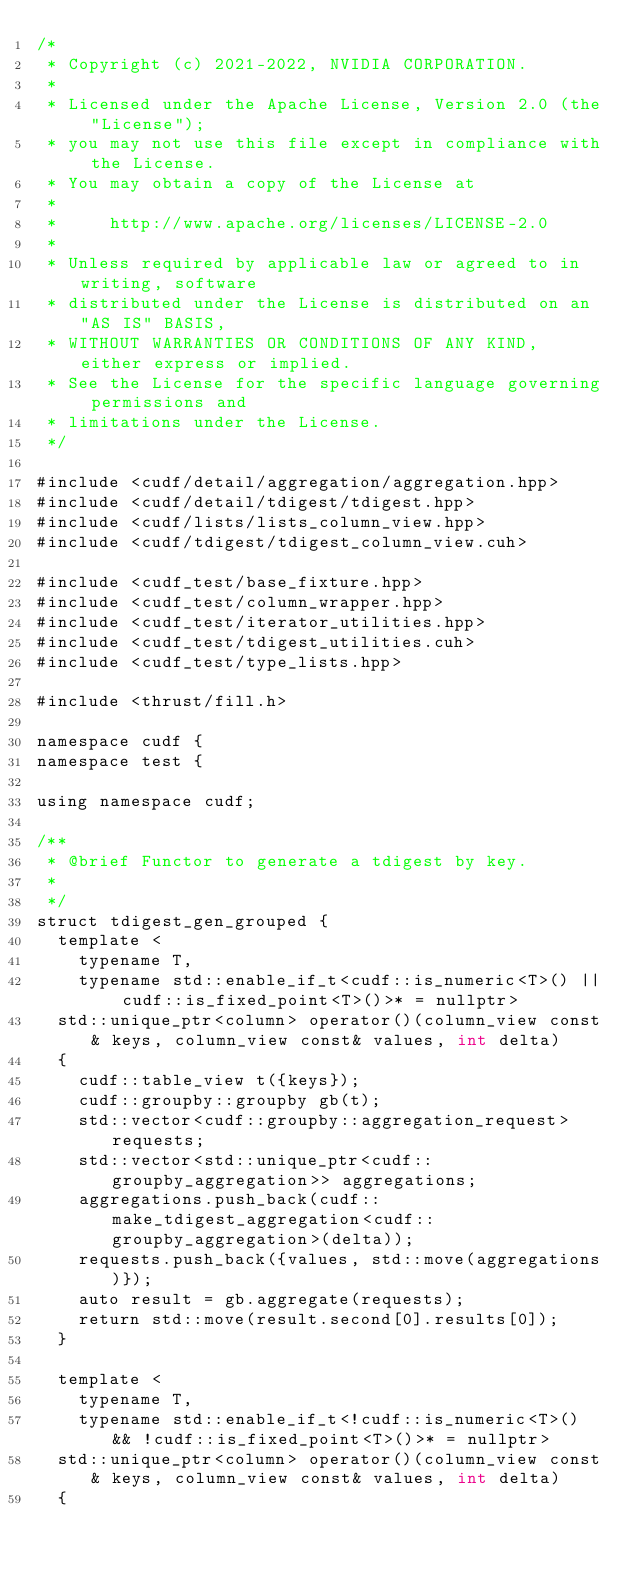Convert code to text. <code><loc_0><loc_0><loc_500><loc_500><_Cuda_>/*
 * Copyright (c) 2021-2022, NVIDIA CORPORATION.
 *
 * Licensed under the Apache License, Version 2.0 (the "License");
 * you may not use this file except in compliance with the License.
 * You may obtain a copy of the License at
 *
 *     http://www.apache.org/licenses/LICENSE-2.0
 *
 * Unless required by applicable law or agreed to in writing, software
 * distributed under the License is distributed on an "AS IS" BASIS,
 * WITHOUT WARRANTIES OR CONDITIONS OF ANY KIND, either express or implied.
 * See the License for the specific language governing permissions and
 * limitations under the License.
 */

#include <cudf/detail/aggregation/aggregation.hpp>
#include <cudf/detail/tdigest/tdigest.hpp>
#include <cudf/lists/lists_column_view.hpp>
#include <cudf/tdigest/tdigest_column_view.cuh>

#include <cudf_test/base_fixture.hpp>
#include <cudf_test/column_wrapper.hpp>
#include <cudf_test/iterator_utilities.hpp>
#include <cudf_test/tdigest_utilities.cuh>
#include <cudf_test/type_lists.hpp>

#include <thrust/fill.h>

namespace cudf {
namespace test {

using namespace cudf;

/**
 * @brief Functor to generate a tdigest by key.
 *
 */
struct tdigest_gen_grouped {
  template <
    typename T,
    typename std::enable_if_t<cudf::is_numeric<T>() || cudf::is_fixed_point<T>()>* = nullptr>
  std::unique_ptr<column> operator()(column_view const& keys, column_view const& values, int delta)
  {
    cudf::table_view t({keys});
    cudf::groupby::groupby gb(t);
    std::vector<cudf::groupby::aggregation_request> requests;
    std::vector<std::unique_ptr<cudf::groupby_aggregation>> aggregations;
    aggregations.push_back(cudf::make_tdigest_aggregation<cudf::groupby_aggregation>(delta));
    requests.push_back({values, std::move(aggregations)});
    auto result = gb.aggregate(requests);
    return std::move(result.second[0].results[0]);
  }

  template <
    typename T,
    typename std::enable_if_t<!cudf::is_numeric<T>() && !cudf::is_fixed_point<T>()>* = nullptr>
  std::unique_ptr<column> operator()(column_view const& keys, column_view const& values, int delta)
  {</code> 